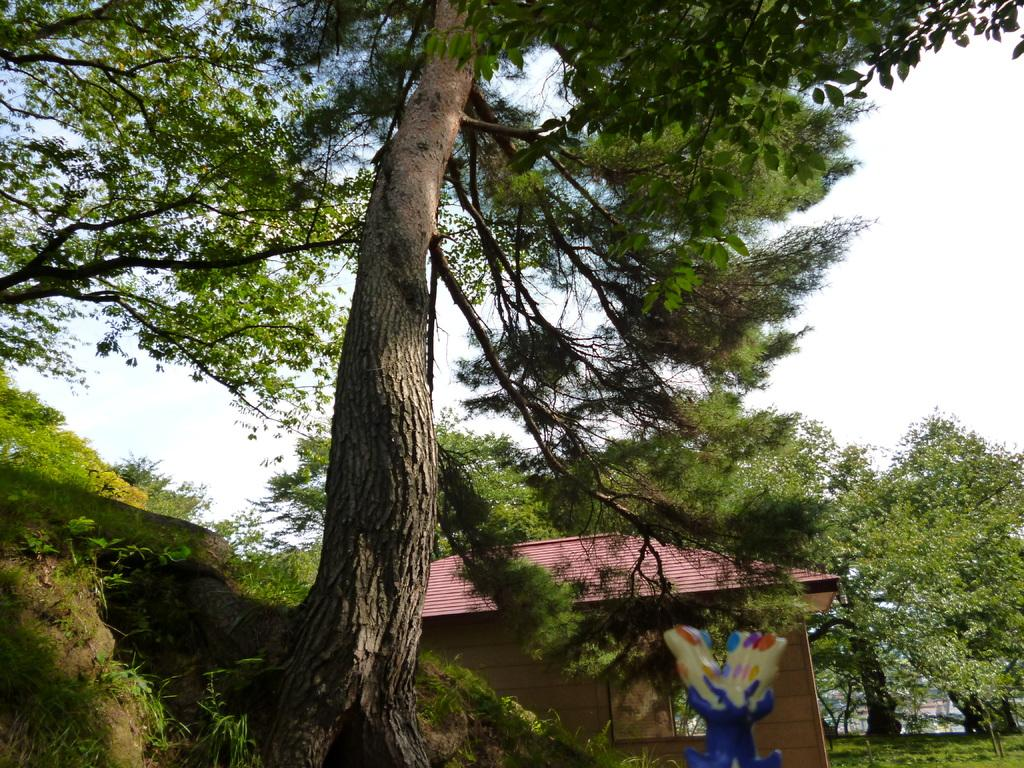What is located in the center of the image? There are trees, a house, hills, and grass in the center of the image. What type of vegetation is present in the image? Trees and grass are present in the image. What type of terrain is visible in the image? Hills are visible in the image. What is visible at the bottom of the image? The ground is visible at the bottom of the image. What is visible at the top of the image? The sky is visible at the top of the image. What type of metal is used to construct the religious building in the image? There is no religious building present in the image; it features trees, a house, hills, and grass in the center. How does the growth of the trees in the image compare to the growth of trees in a different climate? The image does not provide enough information to compare the growth of the trees to trees in a different climate. 